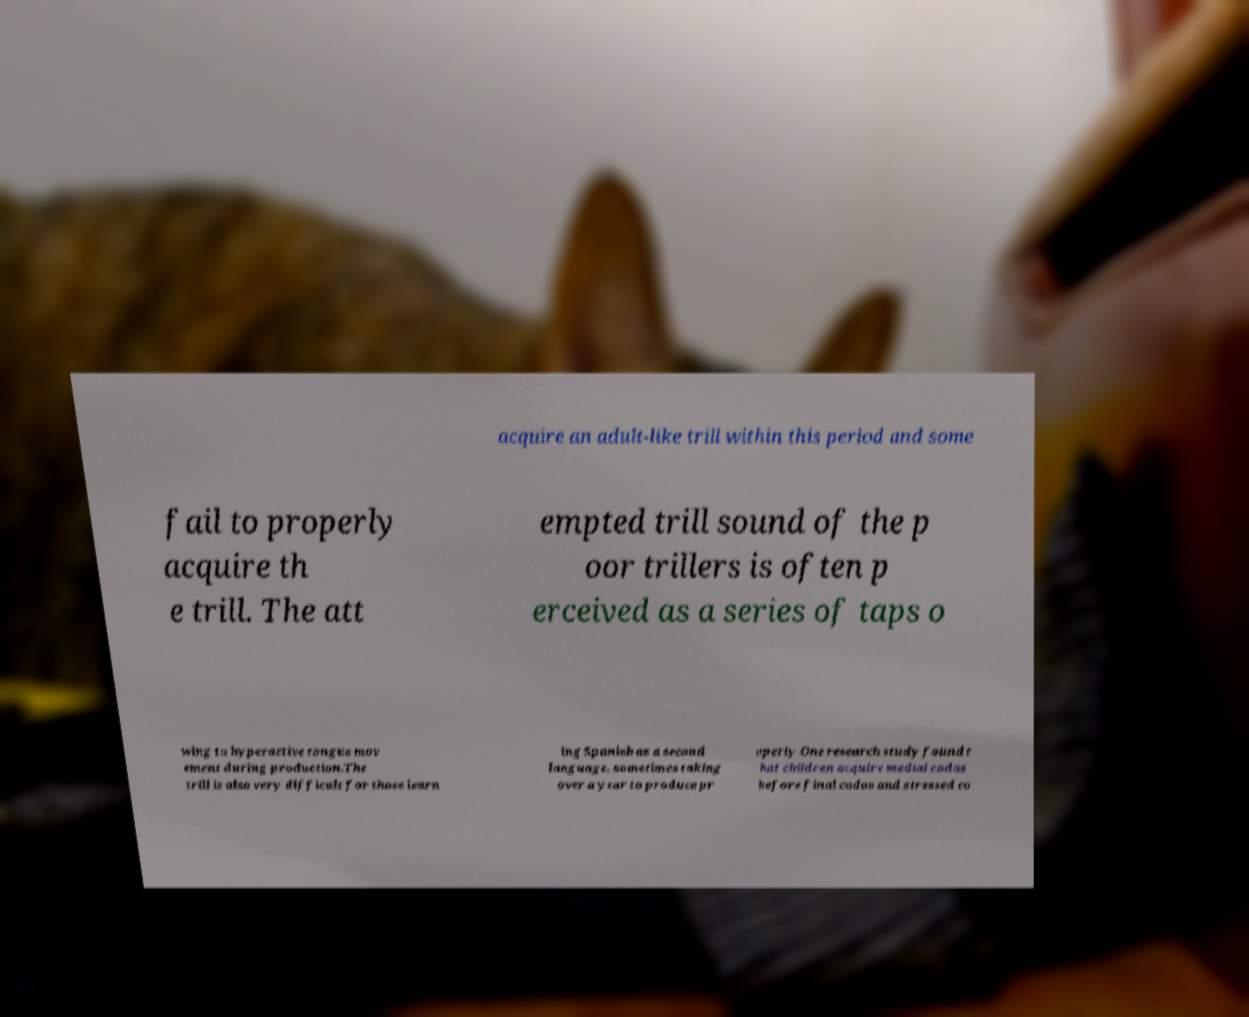Can you accurately transcribe the text from the provided image for me? acquire an adult-like trill within this period and some fail to properly acquire th e trill. The att empted trill sound of the p oor trillers is often p erceived as a series of taps o wing to hyperactive tongue mov ement during production.The trill is also very difficult for those learn ing Spanish as a second language, sometimes taking over a year to produce pr operly.One research study found t hat children acquire medial codas before final codas and stressed co 